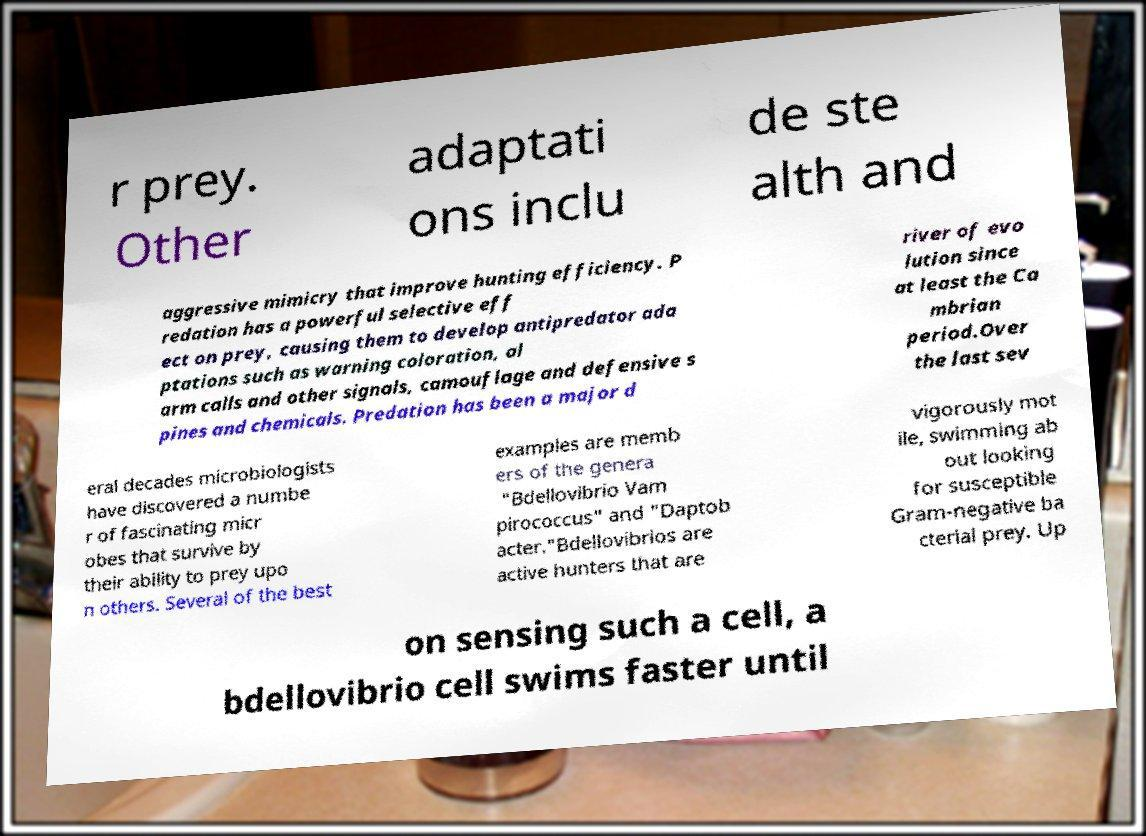Can you accurately transcribe the text from the provided image for me? r prey. Other adaptati ons inclu de ste alth and aggressive mimicry that improve hunting efficiency. P redation has a powerful selective eff ect on prey, causing them to develop antipredator ada ptations such as warning coloration, al arm calls and other signals, camouflage and defensive s pines and chemicals. Predation has been a major d river of evo lution since at least the Ca mbrian period.Over the last sev eral decades microbiologists have discovered a numbe r of fascinating micr obes that survive by their ability to prey upo n others. Several of the best examples are memb ers of the genera "Bdellovibrio Vam pirococcus" and "Daptob acter."Bdellovibrios are active hunters that are vigorously mot ile, swimming ab out looking for susceptible Gram-negative ba cterial prey. Up on sensing such a cell, a bdellovibrio cell swims faster until 